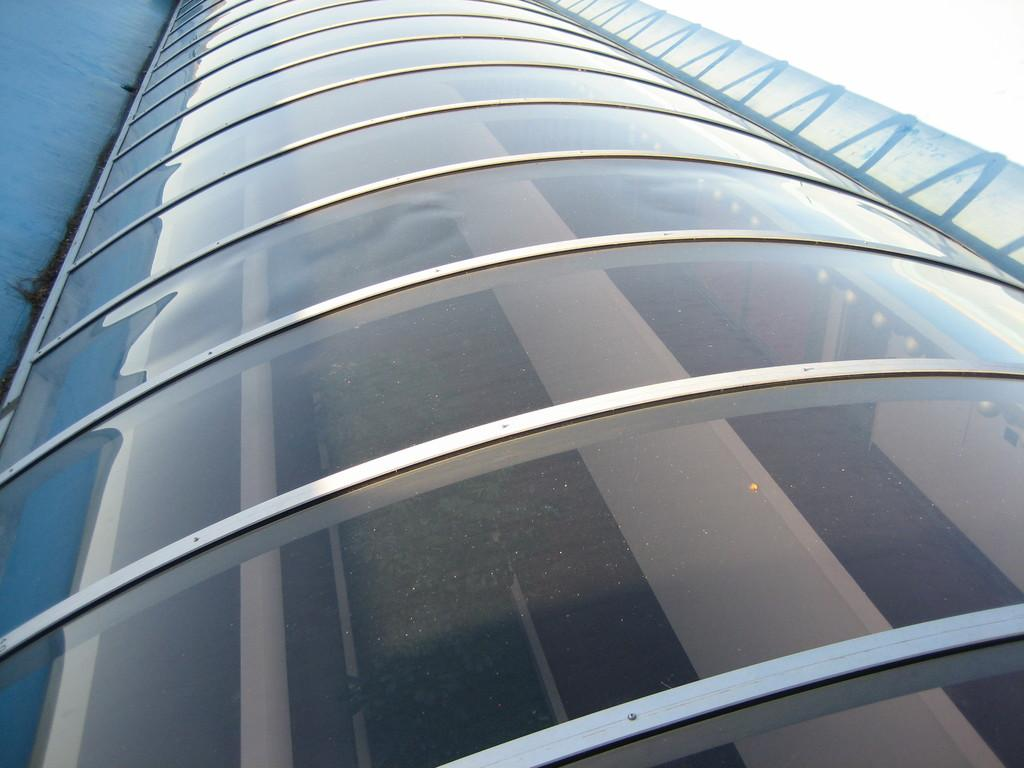What type of building is depicted in the image? There is a glass building in the image. What type of sponge can be heard singing in the image? There is no sponge present in the image, and therefore no such activity can be observed. 